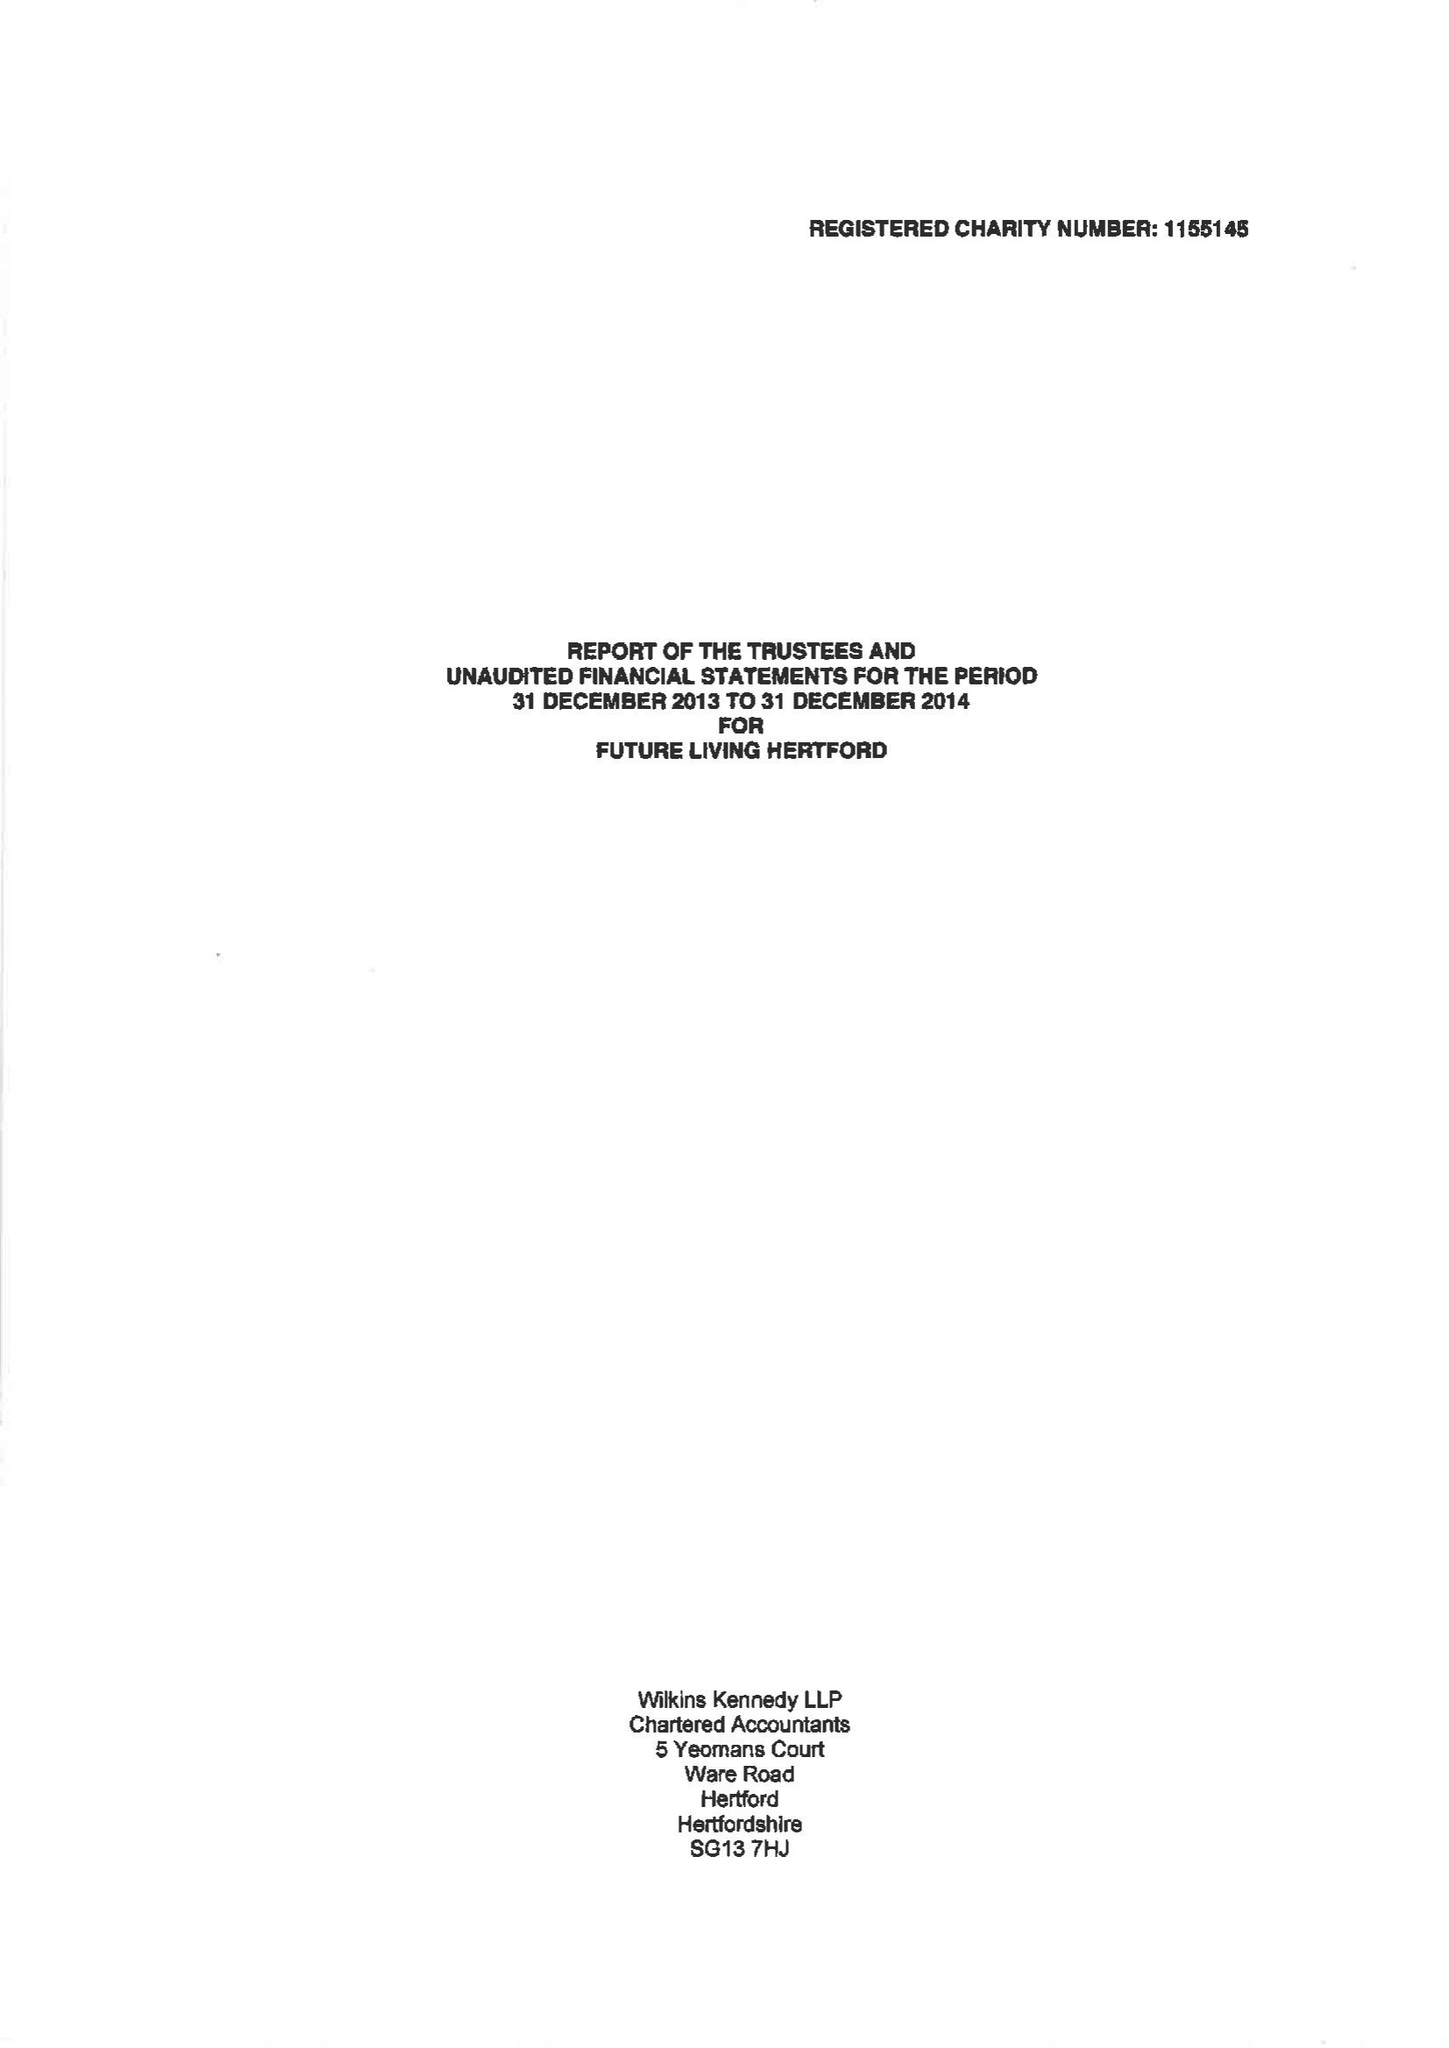What is the value for the charity_name?
Answer the question using a single word or phrase. Future Living Hertford 